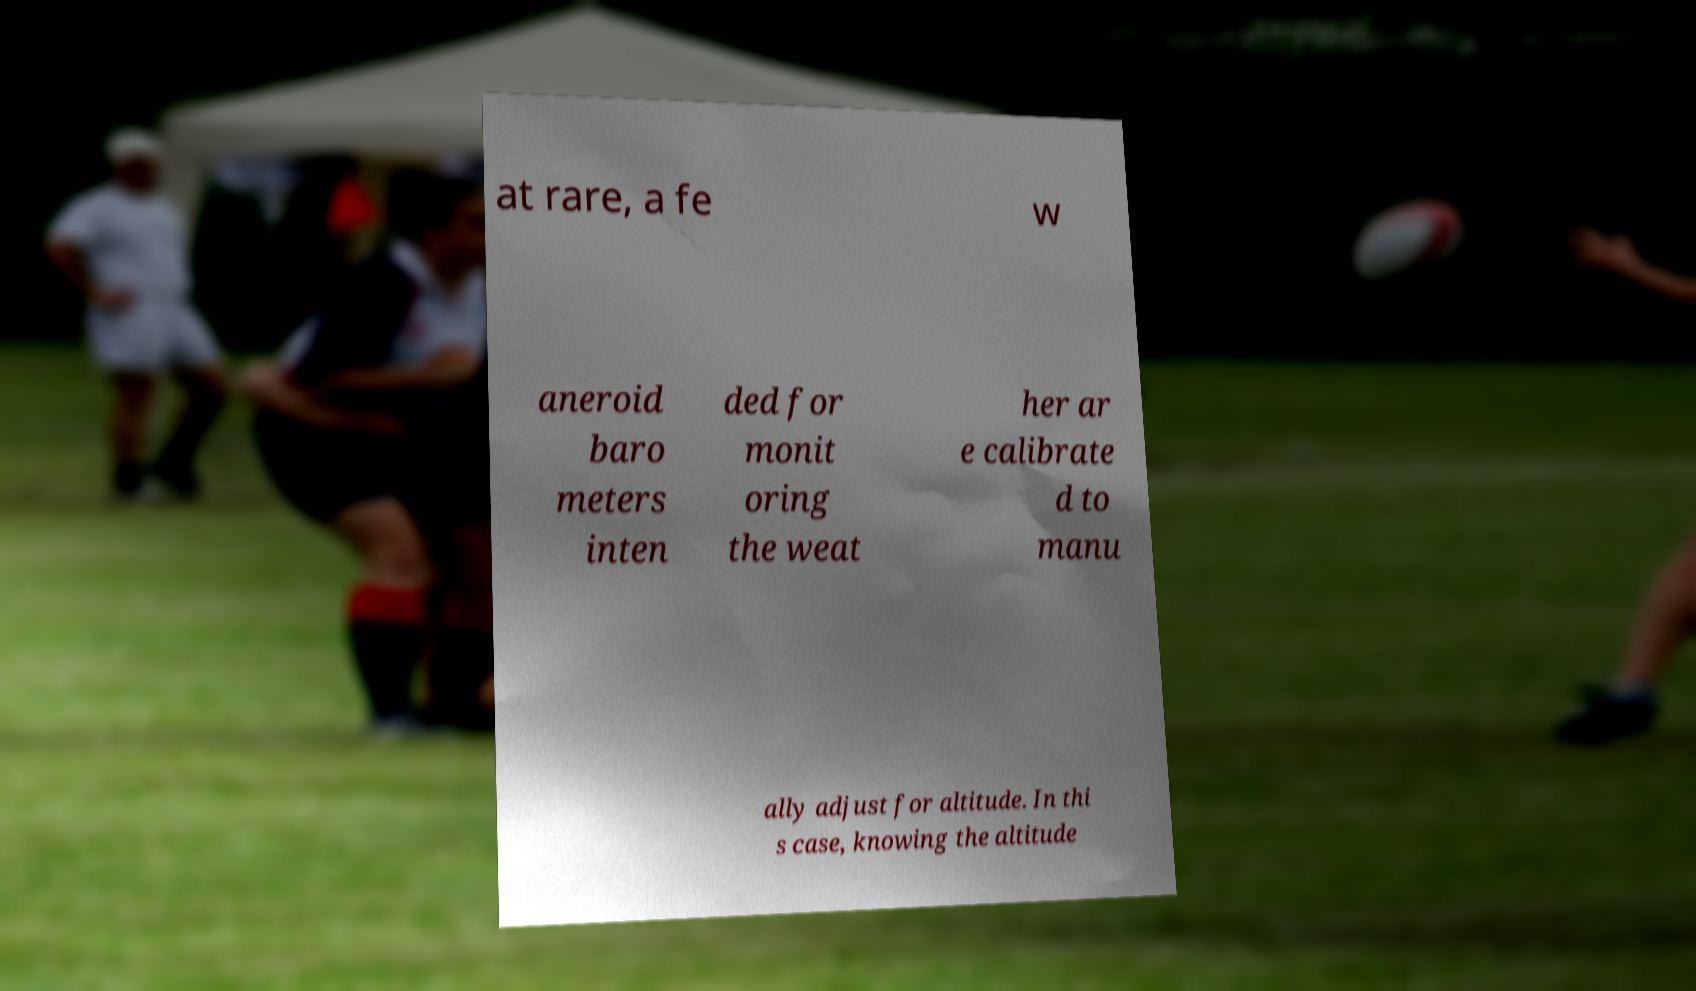Can you read and provide the text displayed in the image?This photo seems to have some interesting text. Can you extract and type it out for me? at rare, a fe w aneroid baro meters inten ded for monit oring the weat her ar e calibrate d to manu ally adjust for altitude. In thi s case, knowing the altitude 